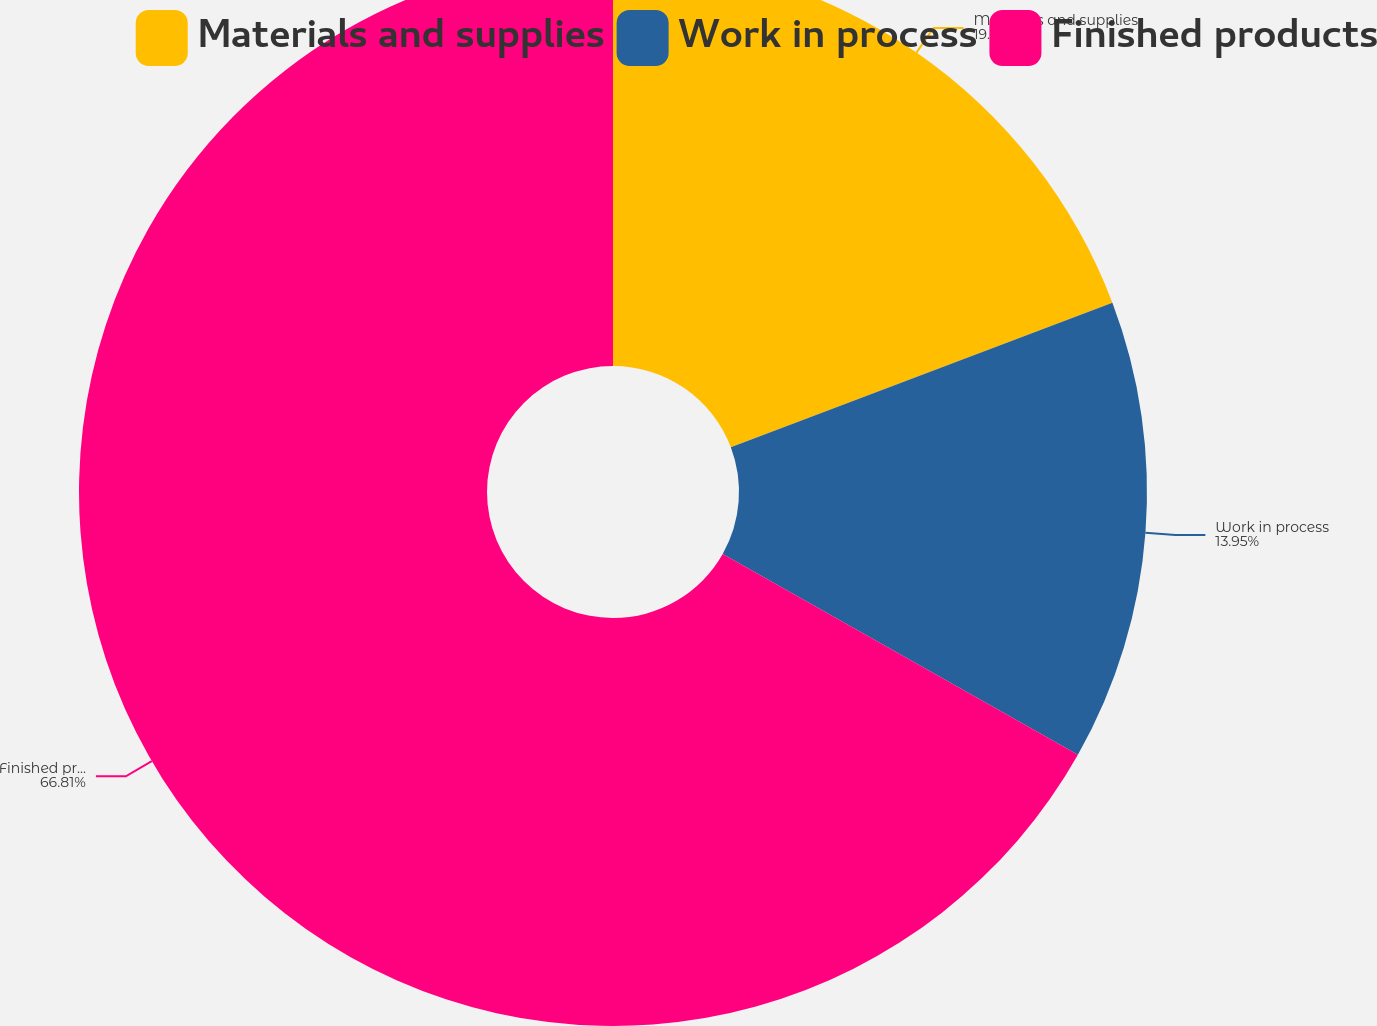Convert chart to OTSL. <chart><loc_0><loc_0><loc_500><loc_500><pie_chart><fcel>Materials and supplies<fcel>Work in process<fcel>Finished products<nl><fcel>19.24%<fcel>13.95%<fcel>66.82%<nl></chart> 